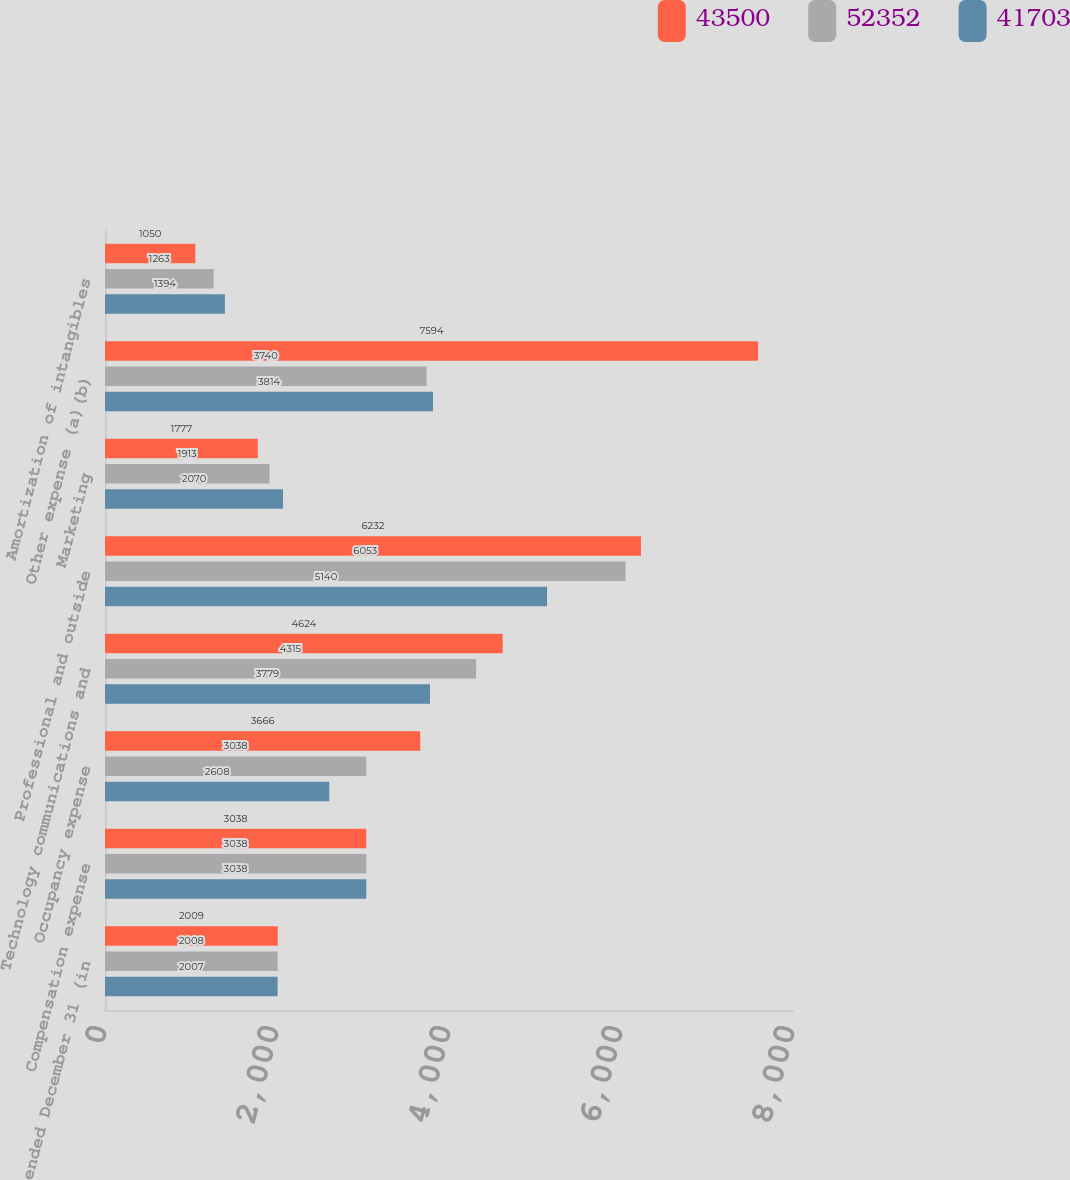<chart> <loc_0><loc_0><loc_500><loc_500><stacked_bar_chart><ecel><fcel>Year ended December 31 (in<fcel>Compensation expense<fcel>Occupancy expense<fcel>Technology communications and<fcel>Professional and outside<fcel>Marketing<fcel>Other expense (a)(b)<fcel>Amortization of intangibles<nl><fcel>43500<fcel>2009<fcel>3038<fcel>3666<fcel>4624<fcel>6232<fcel>1777<fcel>7594<fcel>1050<nl><fcel>52352<fcel>2008<fcel>3038<fcel>3038<fcel>4315<fcel>6053<fcel>1913<fcel>3740<fcel>1263<nl><fcel>41703<fcel>2007<fcel>3038<fcel>2608<fcel>3779<fcel>5140<fcel>2070<fcel>3814<fcel>1394<nl></chart> 